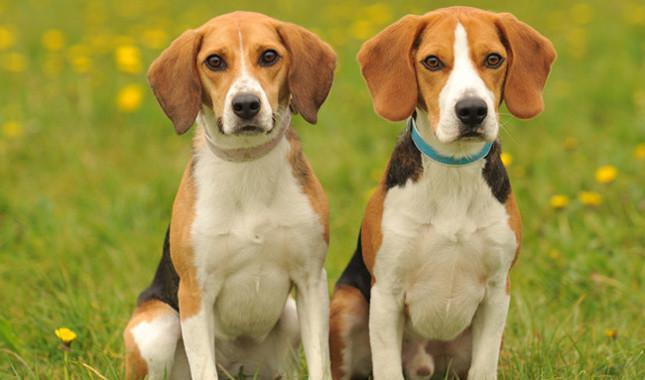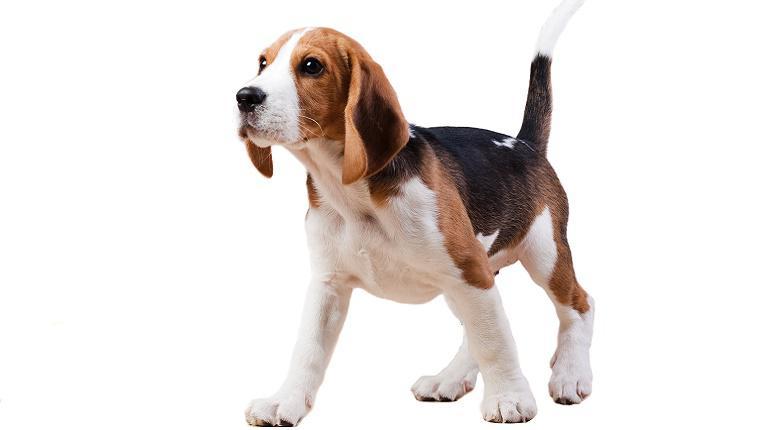The first image is the image on the left, the second image is the image on the right. For the images displayed, is the sentence "There are 2 dogs standing on all fours in the right image." factually correct? Answer yes or no. No. 